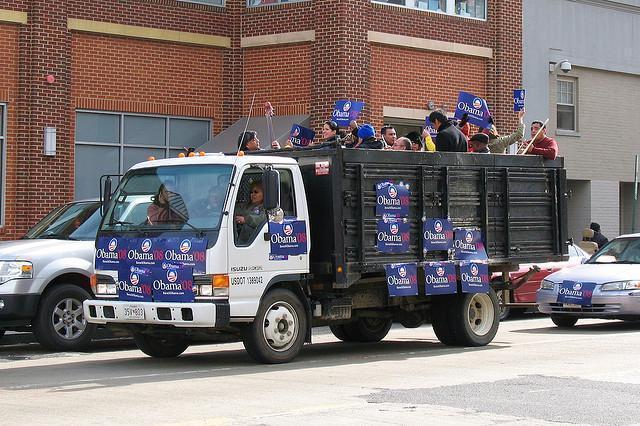Who did they want to be Vice President?
Select the accurate response from the four choices given to answer the question.
Options: Pence, palin, clinton, biden. Biden. 